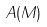Convert formula to latex. <formula><loc_0><loc_0><loc_500><loc_500>A ( M )</formula> 